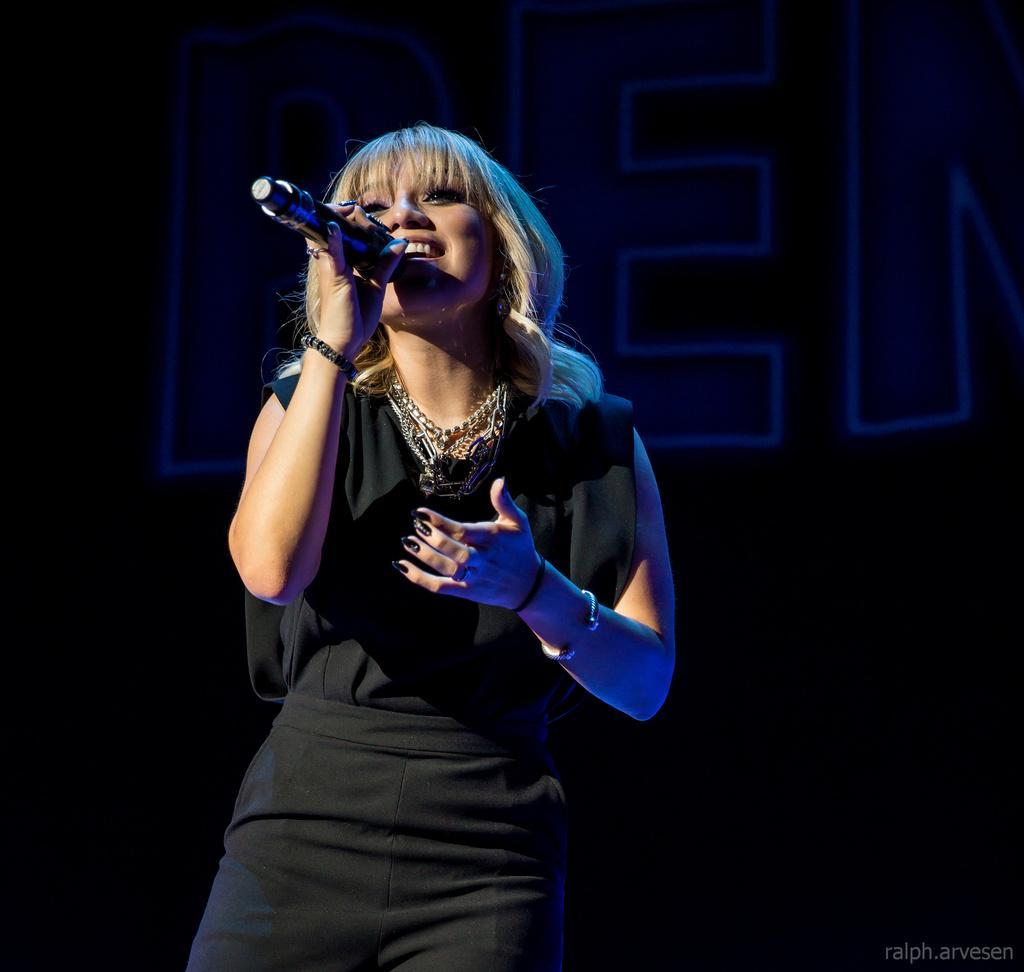In one or two sentences, can you explain what this image depicts? In this image I see a woman who is wearing black dress and I see that she is holding a mic in her hand and I see the watermark over here and it is dark in the background and I see alphabets over here. 